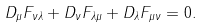<formula> <loc_0><loc_0><loc_500><loc_500>D _ { \mu } F _ { \nu \lambda } + D _ { \nu } F _ { \lambda \mu } + D _ { \lambda } F _ { \mu \nu } = 0 .</formula> 